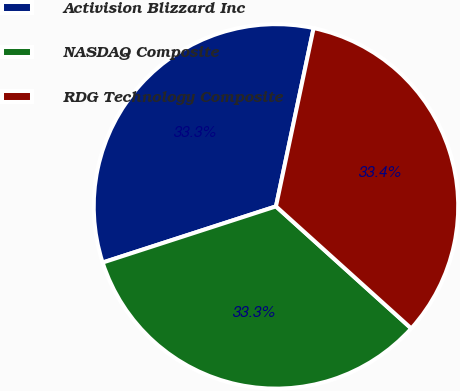<chart> <loc_0><loc_0><loc_500><loc_500><pie_chart><fcel>Activision Blizzard Inc<fcel>NASDAQ Composite<fcel>RDG Technology Composite<nl><fcel>33.3%<fcel>33.33%<fcel>33.37%<nl></chart> 